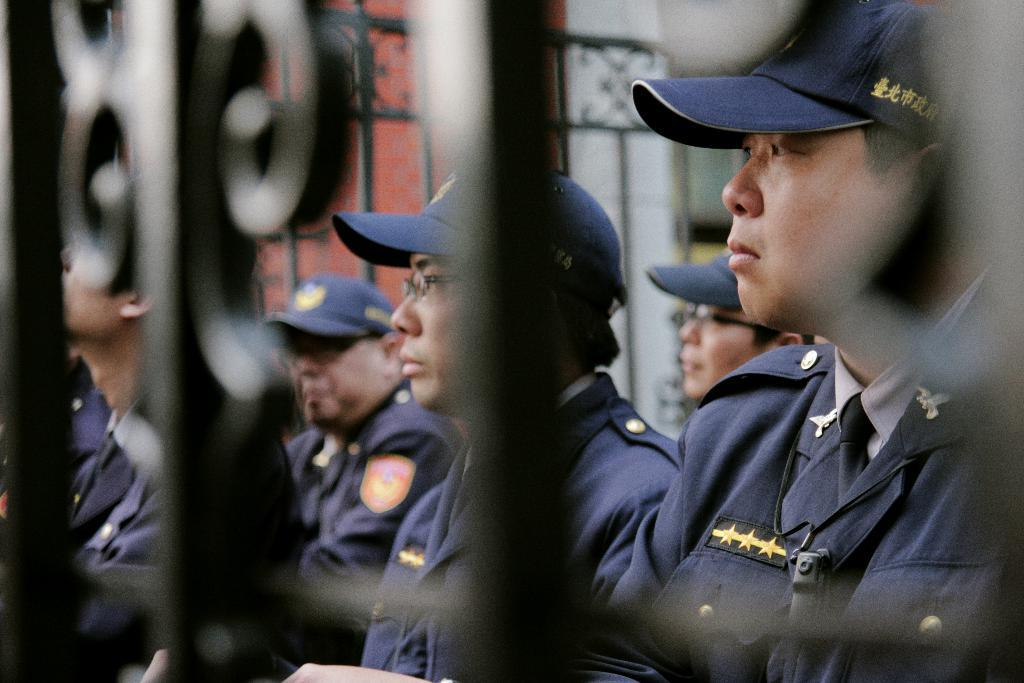What are the people in the image wearing? The people in the image are wearing uniforms. Are there any accessories visible on the people's heads? Yes, some of the people are wearing caps. Are there any people wearing eyewear in the image? Yes, some people are wearing glasses. What type of structure can be seen in the image? There is a wall visible in the image. What architectural feature can be seen in the image? There are grilles visible in the image. Reasoning: Let's think step by identifying the main subjects and objects in the image based on the provided facts. We then formulate questions that focus on the appearance and characteristics of these subjects and objects, ensuring that each question can be answered definitively with the information given. We avoid yes/no questions and ensure that the language is simple and clear. Absurd Question/Answer: What type of cakes are being served on the grilles in the image? There are no cakes present in the image; the grilles are a structural feature. What type of drain can be seen on the wall in the image? A: There is no drain visible on the wall in the image. 